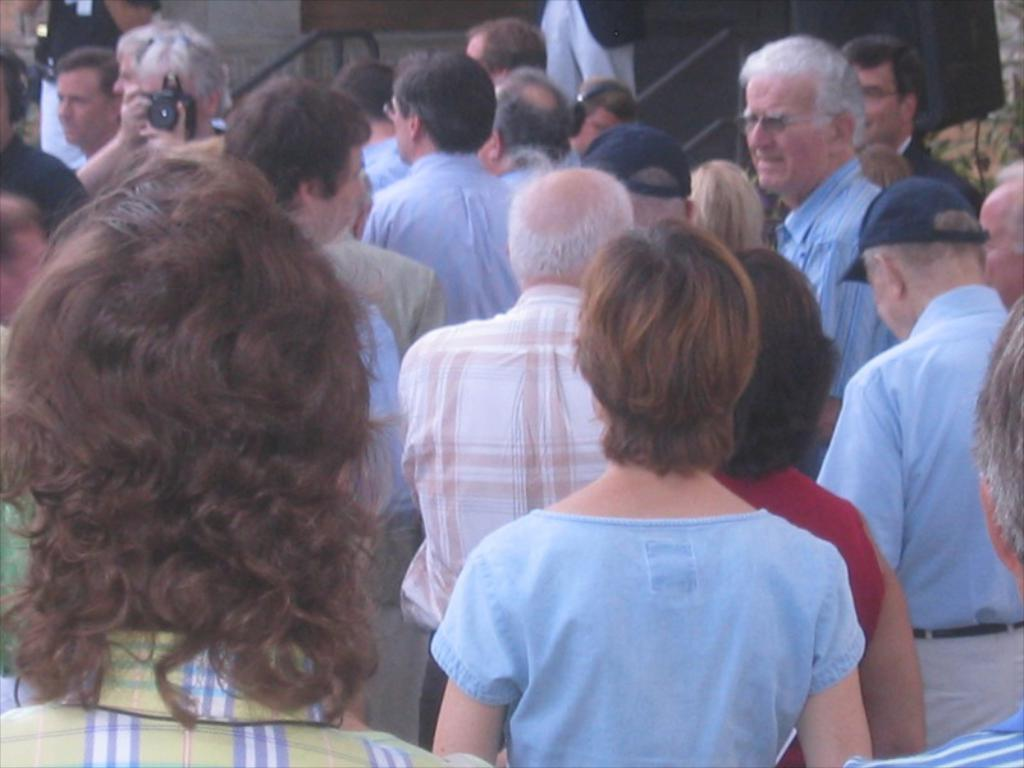What are the people in the image doing? The people in the image are standing. What is the man holding in the image? The man is holding a camera in the image. What is the man doing with the camera? The man is taking a picture. What can be seen in the background of the image? There is a building visible in the background of the image. What type of bean is being ordered by the people in the image? There is no mention of beans or ordering in the image; the people are standing, and the man is taking a picture. 